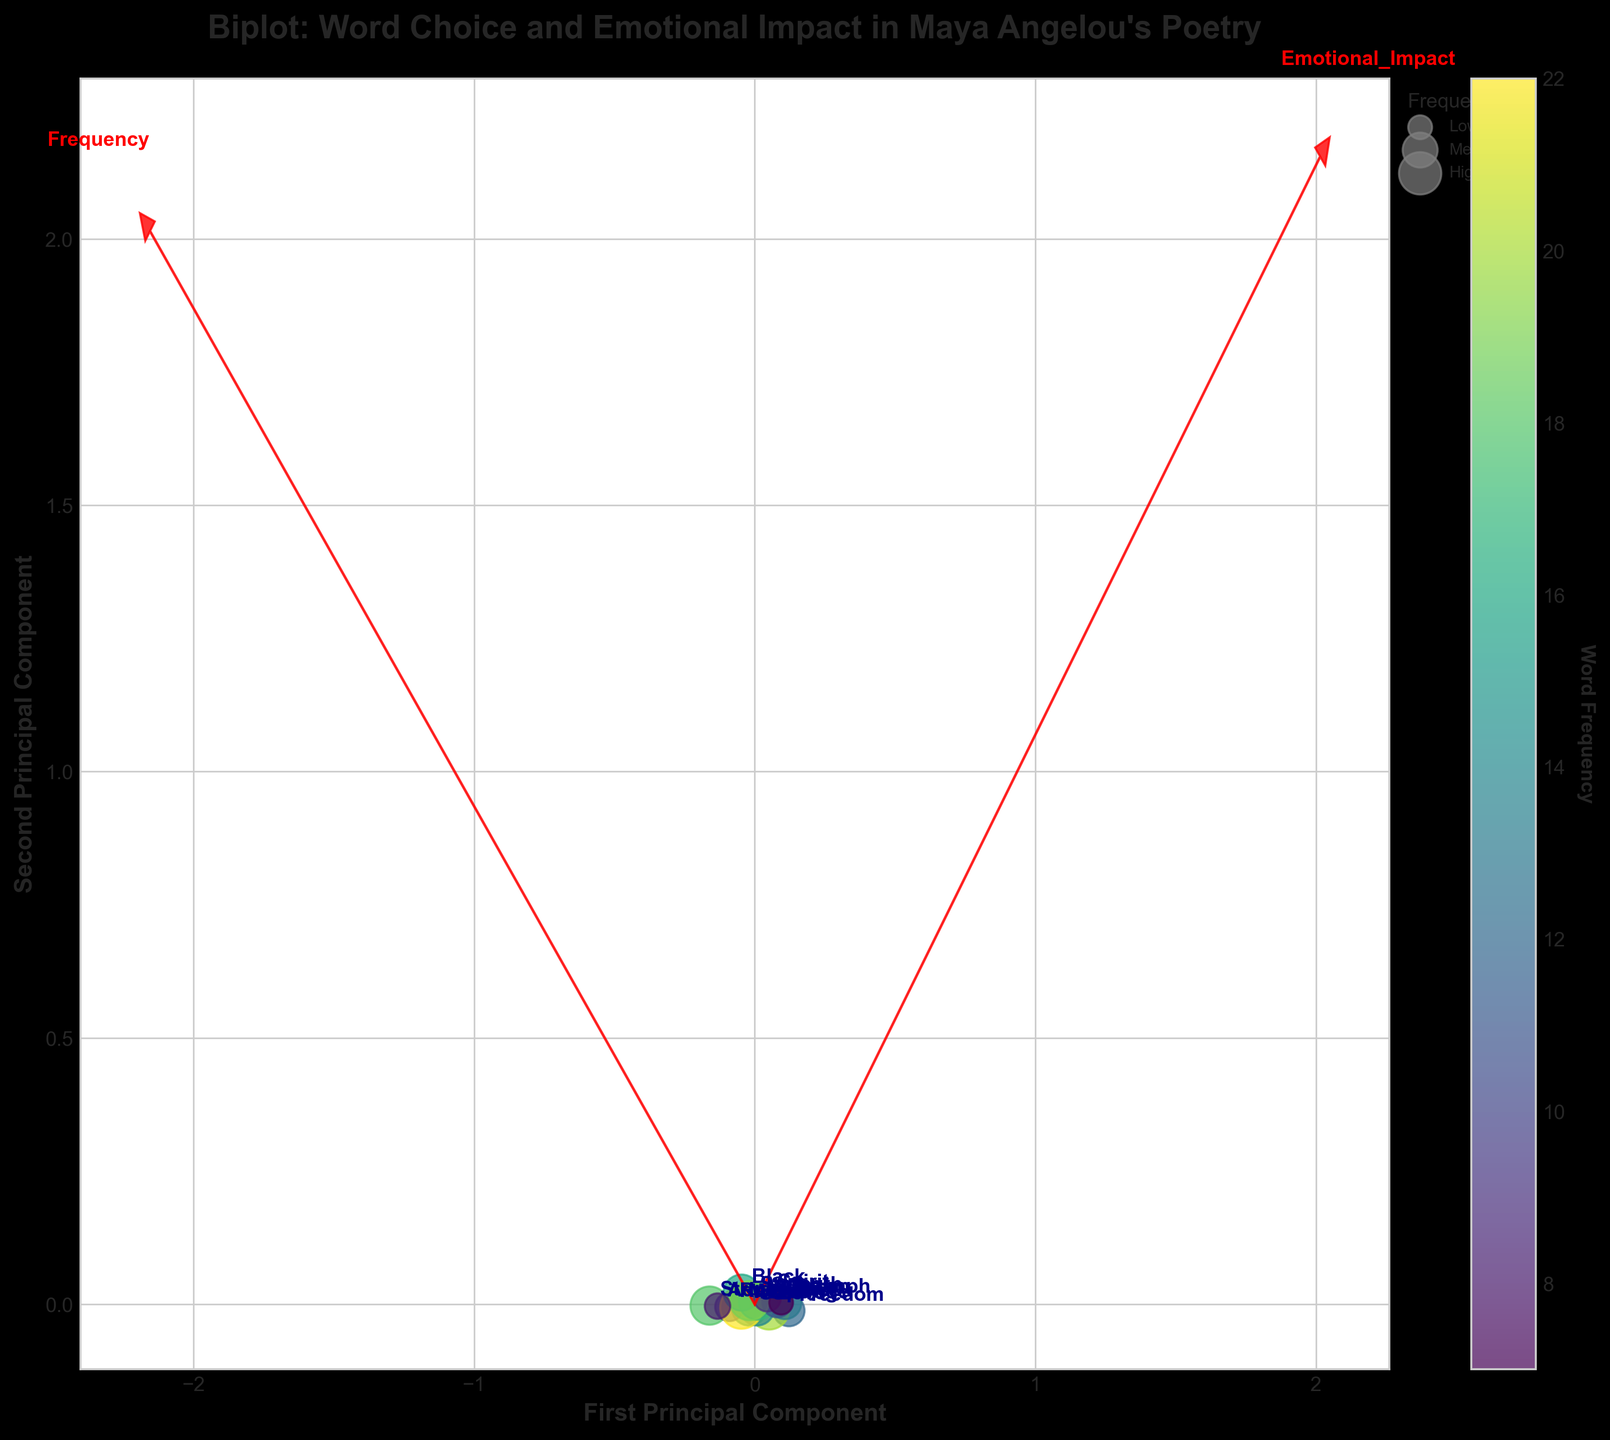What is the title of the biplot? The title of the biplot is located at the top center of the plot and generally serves as a brief summary of the content.
Answer: Biplot: Word Choice and Emotional Impact in Maya Angelou's Poetry How many words are represented in the biplot? The number of words can be counted by looking at the individual points or annotations in the figure. Each annotation corresponds to a word.
Answer: 15 What does the colorbar represent? The colorbar is typically positioned next to the main plot and indicates that it denotes the word frequency with a gradient of colors.
Answer: Word Frequency Which principal component is represented on the x-axis? The label of the x-axis identifies which principal component it represents.
Answer: First Principal Component Which word has the highest combined Emotional Impact and Imagery Strength? By examining the scatter plot, the point that is furthest along both axes (indicating high values in both Emotional Impact and Imagery Strength) represents the word with the highest combined values.
Answer: Rise How does the word 'Love' compare in frequency to the word 'Strength'? By locating 'Love' and 'Strength' on the map, we can compare the size of their scatter points since the size indicates frequency.
Answer: Love has fewer frequencies than Strength Which two words are closest to each other in terms of their principal component scores? Observing the scatter plot, we look for the two words whose points are closest together.
Answer: Dream and Triumph Do words with high Emotional Impact tend to align with high Imagery Strength? Analyzing the direction and length of the variable vectors for Emotional Impact and Imagery Strength helps in understanding their alignment.
Answer: Yes, they are closely aligned Among the words 'Hope,' 'Freedom,' and 'Struggle,' which has the lowest Imagery Strength? By identifying these words on the plot and examining their positions relative to the Imagery Strength vector, we can compare their positions.
Answer: Struggle Which word has the strongest visual alignment with the 'Imagery_Strength' vector? Reviewing which word’s point is most aligned and furthest along the Imagery_Strength vector determines the answer.
Answer: Rise 